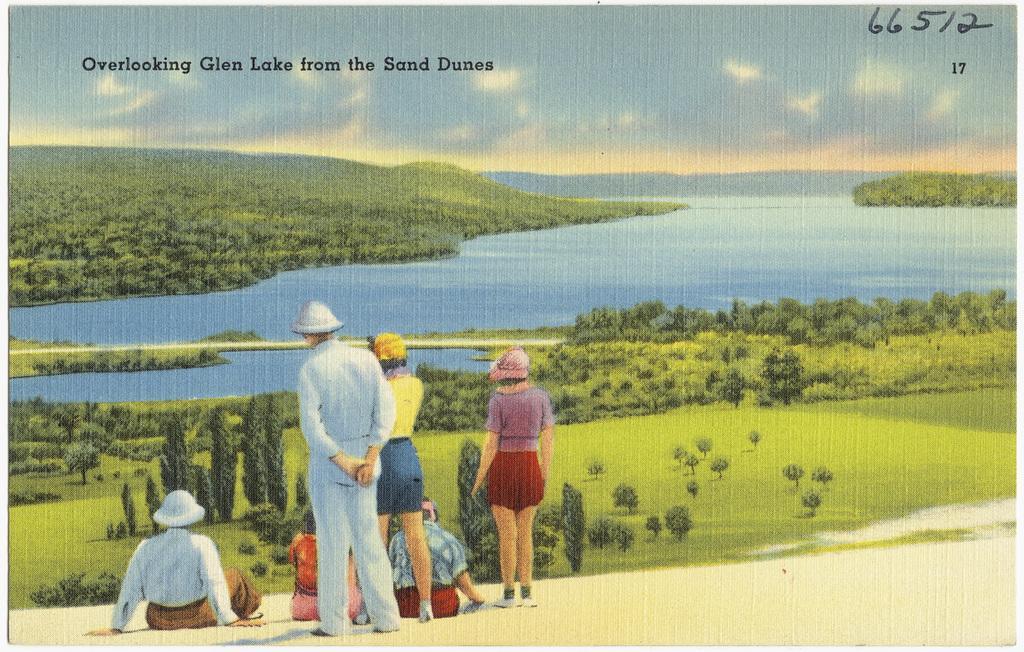Please provide a concise description of this image. In this image there are a few people standing and there are a few people sitting. In front of them there are plants, trees. At the bottom of the image there is grass on the surface. In the background of the image there is water. There are mountains. At the top of the image there are clouds in the sky. There are some text and numbers at the top of the image. 